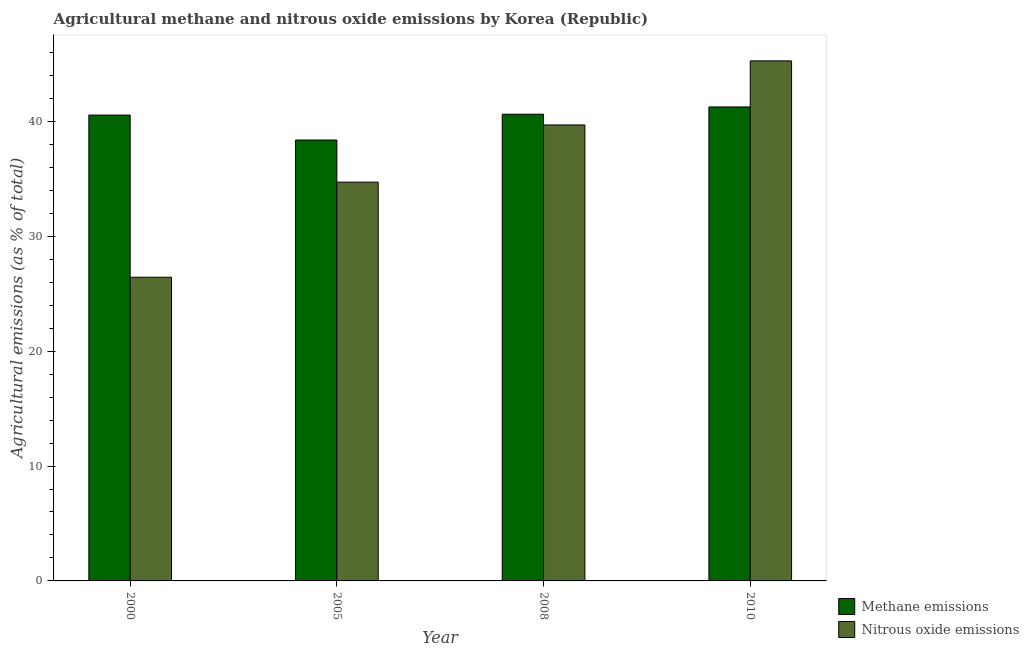How many different coloured bars are there?
Offer a very short reply. 2. How many groups of bars are there?
Your response must be concise. 4. Are the number of bars per tick equal to the number of legend labels?
Provide a short and direct response. Yes. How many bars are there on the 4th tick from the left?
Ensure brevity in your answer.  2. How many bars are there on the 3rd tick from the right?
Keep it short and to the point. 2. What is the label of the 1st group of bars from the left?
Your answer should be very brief. 2000. What is the amount of nitrous oxide emissions in 2005?
Your response must be concise. 34.71. Across all years, what is the maximum amount of methane emissions?
Offer a very short reply. 41.25. Across all years, what is the minimum amount of methane emissions?
Your answer should be very brief. 38.38. In which year was the amount of methane emissions minimum?
Ensure brevity in your answer.  2005. What is the total amount of methane emissions in the graph?
Give a very brief answer. 160.8. What is the difference between the amount of nitrous oxide emissions in 2000 and that in 2005?
Provide a short and direct response. -8.28. What is the difference between the amount of methane emissions in 2005 and the amount of nitrous oxide emissions in 2008?
Give a very brief answer. -2.25. What is the average amount of nitrous oxide emissions per year?
Keep it short and to the point. 36.52. What is the ratio of the amount of nitrous oxide emissions in 2005 to that in 2010?
Provide a succinct answer. 0.77. Is the difference between the amount of nitrous oxide emissions in 2005 and 2008 greater than the difference between the amount of methane emissions in 2005 and 2008?
Offer a terse response. No. What is the difference between the highest and the second highest amount of nitrous oxide emissions?
Offer a terse response. 5.58. What is the difference between the highest and the lowest amount of methane emissions?
Your answer should be compact. 2.88. In how many years, is the amount of nitrous oxide emissions greater than the average amount of nitrous oxide emissions taken over all years?
Keep it short and to the point. 2. Is the sum of the amount of nitrous oxide emissions in 2005 and 2008 greater than the maximum amount of methane emissions across all years?
Offer a very short reply. Yes. What does the 1st bar from the left in 2010 represents?
Provide a succinct answer. Methane emissions. What does the 1st bar from the right in 2010 represents?
Offer a very short reply. Nitrous oxide emissions. How many bars are there?
Ensure brevity in your answer.  8. What is the difference between two consecutive major ticks on the Y-axis?
Your answer should be very brief. 10. Are the values on the major ticks of Y-axis written in scientific E-notation?
Your response must be concise. No. Does the graph contain any zero values?
Keep it short and to the point. No. Does the graph contain grids?
Your answer should be compact. No. How many legend labels are there?
Your answer should be very brief. 2. How are the legend labels stacked?
Offer a very short reply. Vertical. What is the title of the graph?
Your answer should be very brief. Agricultural methane and nitrous oxide emissions by Korea (Republic). What is the label or title of the Y-axis?
Your response must be concise. Agricultural emissions (as % of total). What is the Agricultural emissions (as % of total) in Methane emissions in 2000?
Give a very brief answer. 40.55. What is the Agricultural emissions (as % of total) of Nitrous oxide emissions in 2000?
Ensure brevity in your answer.  26.43. What is the Agricultural emissions (as % of total) of Methane emissions in 2005?
Offer a terse response. 38.38. What is the Agricultural emissions (as % of total) in Nitrous oxide emissions in 2005?
Keep it short and to the point. 34.71. What is the Agricultural emissions (as % of total) in Methane emissions in 2008?
Your answer should be very brief. 40.62. What is the Agricultural emissions (as % of total) in Nitrous oxide emissions in 2008?
Provide a succinct answer. 39.69. What is the Agricultural emissions (as % of total) of Methane emissions in 2010?
Provide a short and direct response. 41.25. What is the Agricultural emissions (as % of total) in Nitrous oxide emissions in 2010?
Ensure brevity in your answer.  45.26. Across all years, what is the maximum Agricultural emissions (as % of total) of Methane emissions?
Make the answer very short. 41.25. Across all years, what is the maximum Agricultural emissions (as % of total) of Nitrous oxide emissions?
Keep it short and to the point. 45.26. Across all years, what is the minimum Agricultural emissions (as % of total) in Methane emissions?
Make the answer very short. 38.38. Across all years, what is the minimum Agricultural emissions (as % of total) in Nitrous oxide emissions?
Give a very brief answer. 26.43. What is the total Agricultural emissions (as % of total) in Methane emissions in the graph?
Provide a succinct answer. 160.8. What is the total Agricultural emissions (as % of total) in Nitrous oxide emissions in the graph?
Provide a short and direct response. 146.09. What is the difference between the Agricultural emissions (as % of total) in Methane emissions in 2000 and that in 2005?
Give a very brief answer. 2.17. What is the difference between the Agricultural emissions (as % of total) of Nitrous oxide emissions in 2000 and that in 2005?
Give a very brief answer. -8.28. What is the difference between the Agricultural emissions (as % of total) in Methane emissions in 2000 and that in 2008?
Provide a succinct answer. -0.07. What is the difference between the Agricultural emissions (as % of total) in Nitrous oxide emissions in 2000 and that in 2008?
Make the answer very short. -13.25. What is the difference between the Agricultural emissions (as % of total) of Methane emissions in 2000 and that in 2010?
Keep it short and to the point. -0.71. What is the difference between the Agricultural emissions (as % of total) of Nitrous oxide emissions in 2000 and that in 2010?
Offer a terse response. -18.83. What is the difference between the Agricultural emissions (as % of total) in Methane emissions in 2005 and that in 2008?
Offer a very short reply. -2.25. What is the difference between the Agricultural emissions (as % of total) in Nitrous oxide emissions in 2005 and that in 2008?
Ensure brevity in your answer.  -4.98. What is the difference between the Agricultural emissions (as % of total) in Methane emissions in 2005 and that in 2010?
Offer a terse response. -2.88. What is the difference between the Agricultural emissions (as % of total) in Nitrous oxide emissions in 2005 and that in 2010?
Provide a succinct answer. -10.55. What is the difference between the Agricultural emissions (as % of total) of Methane emissions in 2008 and that in 2010?
Offer a terse response. -0.63. What is the difference between the Agricultural emissions (as % of total) in Nitrous oxide emissions in 2008 and that in 2010?
Offer a very short reply. -5.58. What is the difference between the Agricultural emissions (as % of total) in Methane emissions in 2000 and the Agricultural emissions (as % of total) in Nitrous oxide emissions in 2005?
Your answer should be very brief. 5.84. What is the difference between the Agricultural emissions (as % of total) of Methane emissions in 2000 and the Agricultural emissions (as % of total) of Nitrous oxide emissions in 2008?
Your answer should be compact. 0.86. What is the difference between the Agricultural emissions (as % of total) in Methane emissions in 2000 and the Agricultural emissions (as % of total) in Nitrous oxide emissions in 2010?
Make the answer very short. -4.72. What is the difference between the Agricultural emissions (as % of total) of Methane emissions in 2005 and the Agricultural emissions (as % of total) of Nitrous oxide emissions in 2008?
Make the answer very short. -1.31. What is the difference between the Agricultural emissions (as % of total) of Methane emissions in 2005 and the Agricultural emissions (as % of total) of Nitrous oxide emissions in 2010?
Give a very brief answer. -6.89. What is the difference between the Agricultural emissions (as % of total) in Methane emissions in 2008 and the Agricultural emissions (as % of total) in Nitrous oxide emissions in 2010?
Offer a terse response. -4.64. What is the average Agricultural emissions (as % of total) in Methane emissions per year?
Offer a very short reply. 40.2. What is the average Agricultural emissions (as % of total) of Nitrous oxide emissions per year?
Give a very brief answer. 36.52. In the year 2000, what is the difference between the Agricultural emissions (as % of total) in Methane emissions and Agricultural emissions (as % of total) in Nitrous oxide emissions?
Provide a succinct answer. 14.11. In the year 2005, what is the difference between the Agricultural emissions (as % of total) of Methane emissions and Agricultural emissions (as % of total) of Nitrous oxide emissions?
Your response must be concise. 3.67. In the year 2008, what is the difference between the Agricultural emissions (as % of total) of Methane emissions and Agricultural emissions (as % of total) of Nitrous oxide emissions?
Keep it short and to the point. 0.93. In the year 2010, what is the difference between the Agricultural emissions (as % of total) of Methane emissions and Agricultural emissions (as % of total) of Nitrous oxide emissions?
Provide a succinct answer. -4.01. What is the ratio of the Agricultural emissions (as % of total) of Methane emissions in 2000 to that in 2005?
Provide a succinct answer. 1.06. What is the ratio of the Agricultural emissions (as % of total) in Nitrous oxide emissions in 2000 to that in 2005?
Offer a very short reply. 0.76. What is the ratio of the Agricultural emissions (as % of total) of Nitrous oxide emissions in 2000 to that in 2008?
Give a very brief answer. 0.67. What is the ratio of the Agricultural emissions (as % of total) in Methane emissions in 2000 to that in 2010?
Provide a succinct answer. 0.98. What is the ratio of the Agricultural emissions (as % of total) of Nitrous oxide emissions in 2000 to that in 2010?
Your answer should be very brief. 0.58. What is the ratio of the Agricultural emissions (as % of total) of Methane emissions in 2005 to that in 2008?
Offer a terse response. 0.94. What is the ratio of the Agricultural emissions (as % of total) of Nitrous oxide emissions in 2005 to that in 2008?
Offer a very short reply. 0.87. What is the ratio of the Agricultural emissions (as % of total) in Methane emissions in 2005 to that in 2010?
Keep it short and to the point. 0.93. What is the ratio of the Agricultural emissions (as % of total) of Nitrous oxide emissions in 2005 to that in 2010?
Your answer should be very brief. 0.77. What is the ratio of the Agricultural emissions (as % of total) of Methane emissions in 2008 to that in 2010?
Provide a short and direct response. 0.98. What is the ratio of the Agricultural emissions (as % of total) in Nitrous oxide emissions in 2008 to that in 2010?
Your answer should be very brief. 0.88. What is the difference between the highest and the second highest Agricultural emissions (as % of total) in Methane emissions?
Your answer should be compact. 0.63. What is the difference between the highest and the second highest Agricultural emissions (as % of total) of Nitrous oxide emissions?
Give a very brief answer. 5.58. What is the difference between the highest and the lowest Agricultural emissions (as % of total) of Methane emissions?
Keep it short and to the point. 2.88. What is the difference between the highest and the lowest Agricultural emissions (as % of total) of Nitrous oxide emissions?
Ensure brevity in your answer.  18.83. 